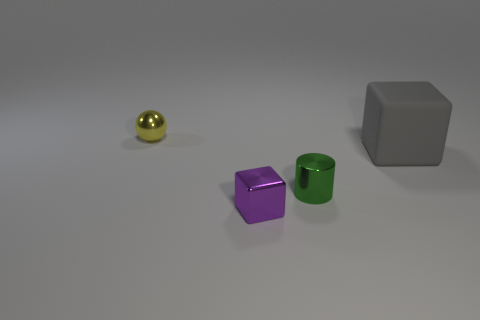Add 4 large purple metal spheres. How many objects exist? 8 Subtract all spheres. How many objects are left? 3 Subtract all rubber blocks. Subtract all gray blocks. How many objects are left? 2 Add 3 small purple metallic objects. How many small purple metallic objects are left? 4 Add 4 large gray rubber things. How many large gray rubber things exist? 5 Subtract 0 red cubes. How many objects are left? 4 